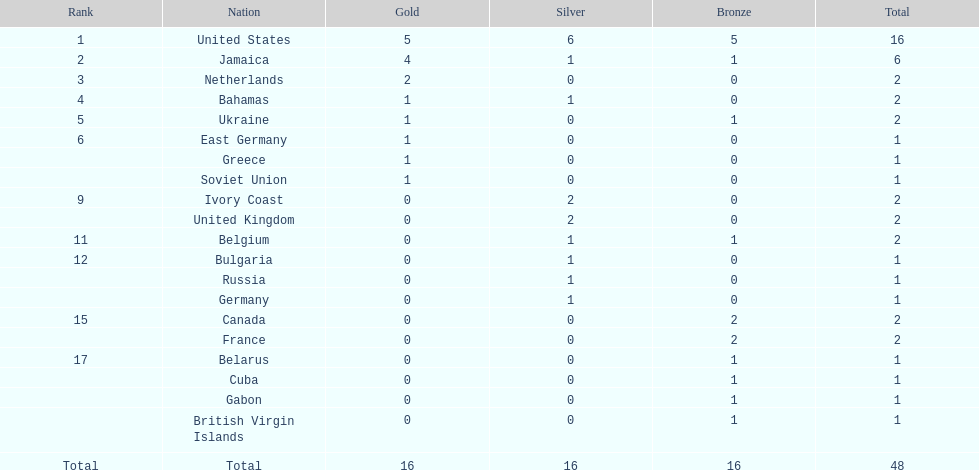Which nation secured the highest number of gold medals? United States. 